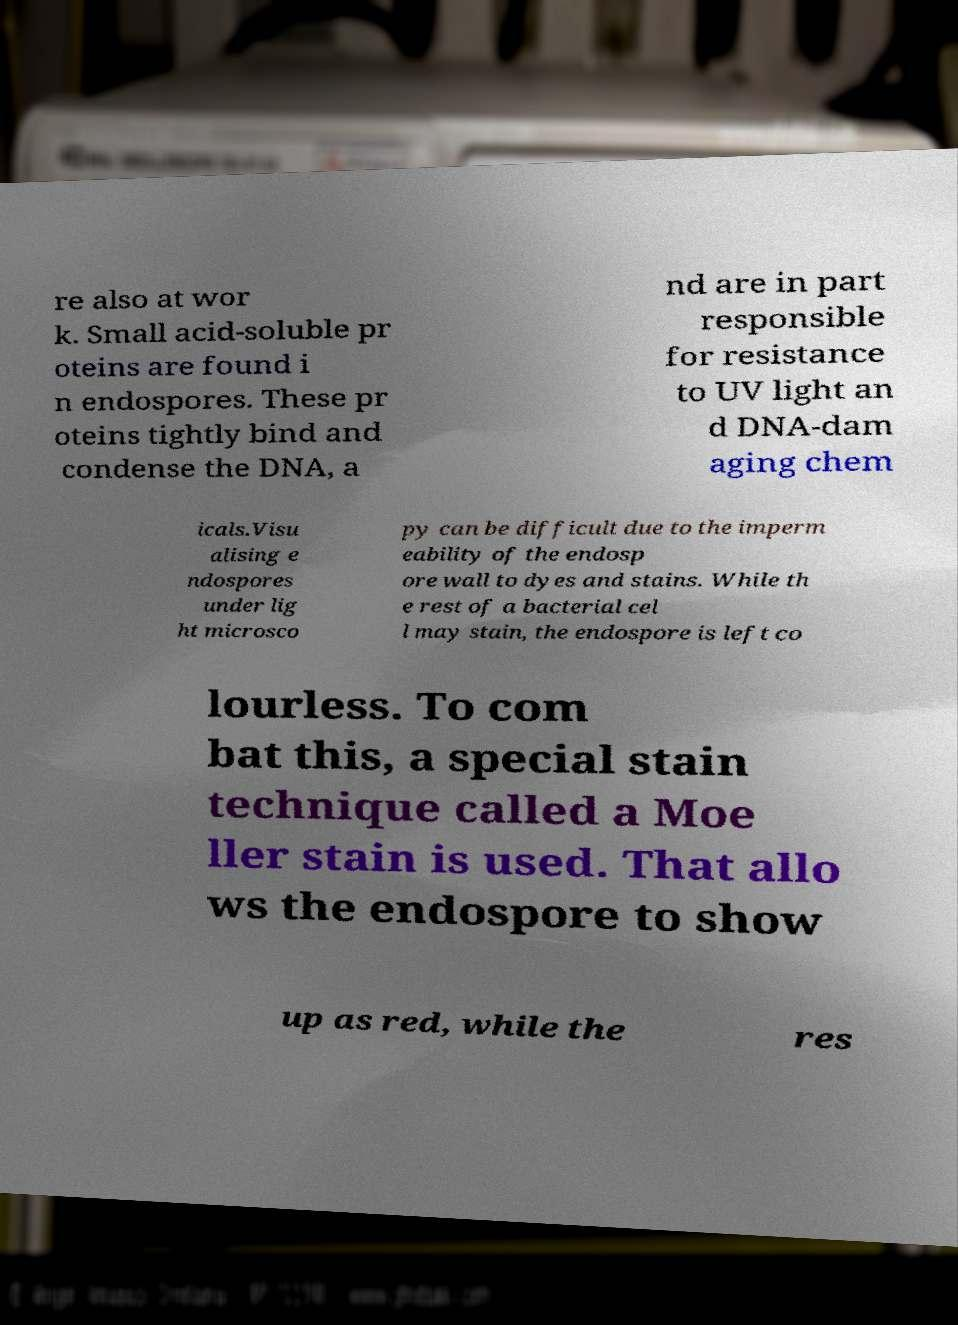What messages or text are displayed in this image? I need them in a readable, typed format. re also at wor k. Small acid-soluble pr oteins are found i n endospores. These pr oteins tightly bind and condense the DNA, a nd are in part responsible for resistance to UV light an d DNA-dam aging chem icals.Visu alising e ndospores under lig ht microsco py can be difficult due to the imperm eability of the endosp ore wall to dyes and stains. While th e rest of a bacterial cel l may stain, the endospore is left co lourless. To com bat this, a special stain technique called a Moe ller stain is used. That allo ws the endospore to show up as red, while the res 